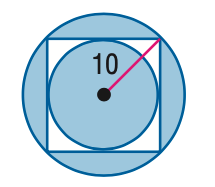Answer the mathemtical geometry problem and directly provide the correct option letter.
Question: Find the area of the shaded region. Assume that all polygons that appear to be regular are regular. Round to the nearest tenth.
Choices: A: 192.7 B: 271.2 C: 371.2 D: 428.3 B 